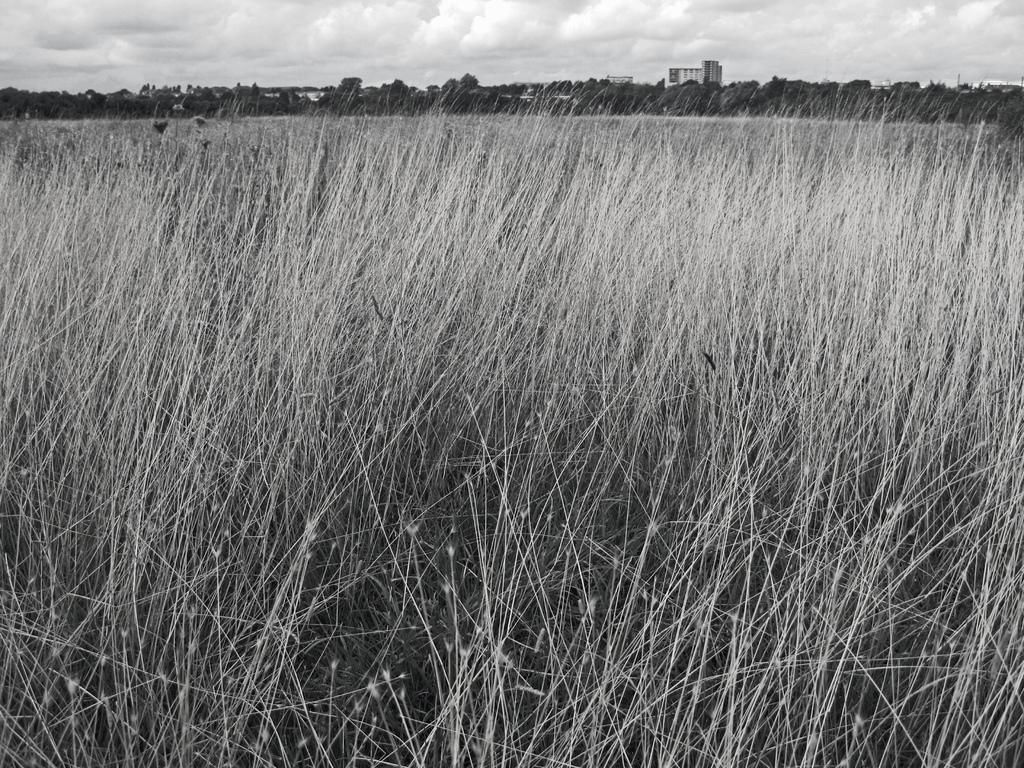What type of vegetation can be seen in the image? There is dried grass in the image. What else is present in the image besides the dried grass? There are trees and buildings in the image. What can be seen in the sky in the image? The sky is visible in the image. What type of coach is driving through the dried grass in the image? There is no coach present in the image; it only features dried grass, trees, buildings, and the sky. 